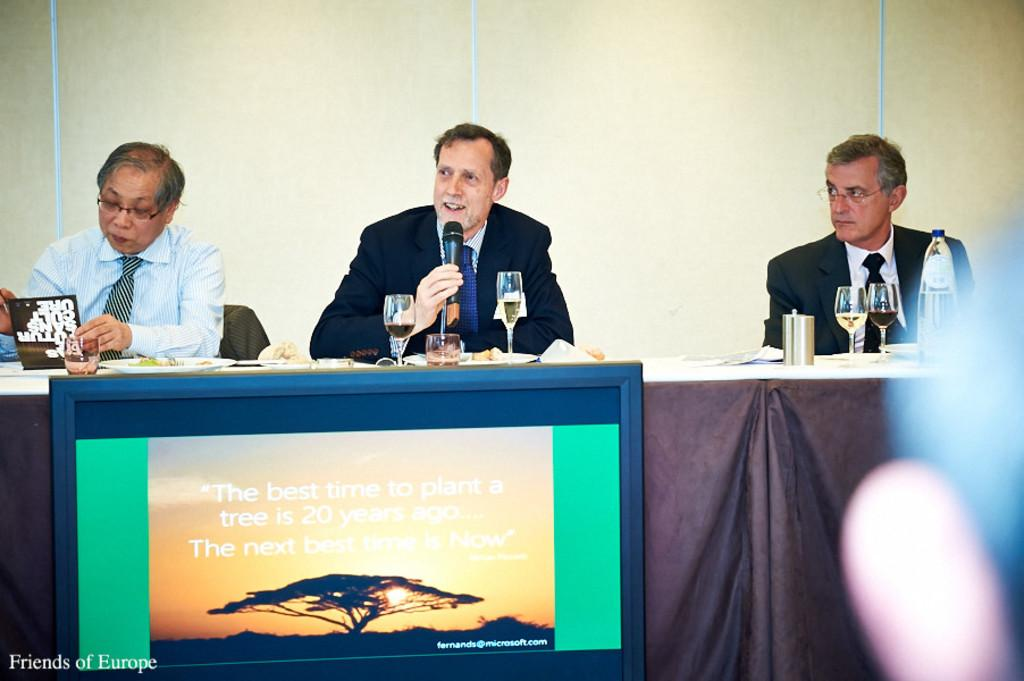<image>
Summarize the visual content of the image. the country of Europe mentioned on a sign in front of men 